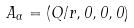<formula> <loc_0><loc_0><loc_500><loc_500>A _ { \alpha } = ( Q / r , 0 , 0 , 0 )</formula> 